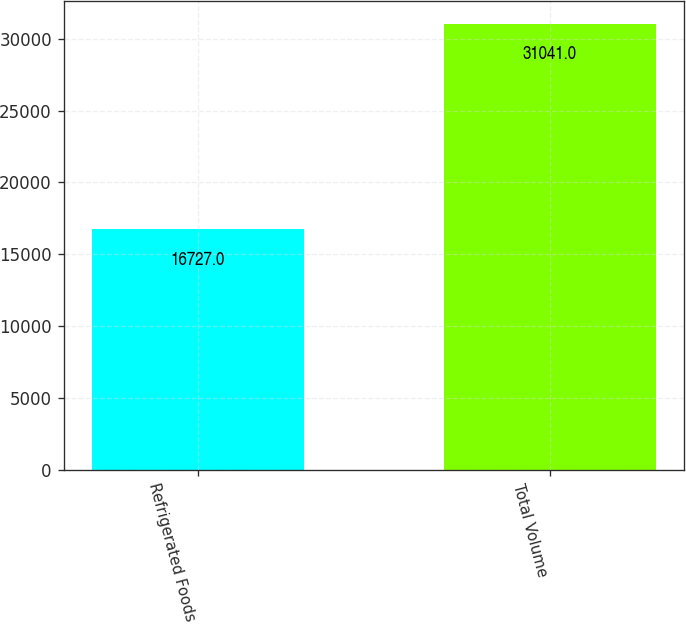Convert chart. <chart><loc_0><loc_0><loc_500><loc_500><bar_chart><fcel>Refrigerated Foods<fcel>Total Volume<nl><fcel>16727<fcel>31041<nl></chart> 